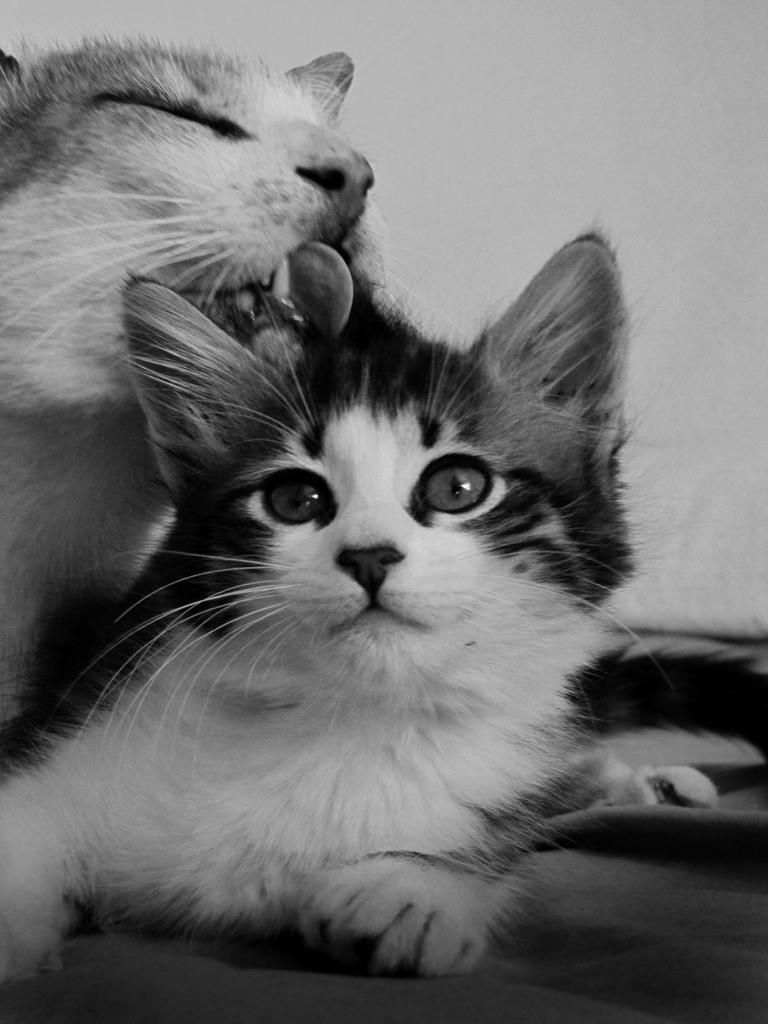Can you describe this image briefly? We can see two cats. In the background it is white. 